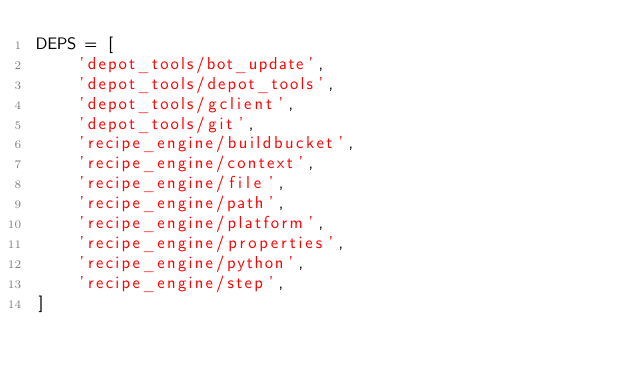Convert code to text. <code><loc_0><loc_0><loc_500><loc_500><_Python_>DEPS = [
    'depot_tools/bot_update',
    'depot_tools/depot_tools',
    'depot_tools/gclient',
    'depot_tools/git',
    'recipe_engine/buildbucket',
    'recipe_engine/context',
    'recipe_engine/file',
    'recipe_engine/path',
    'recipe_engine/platform',
    'recipe_engine/properties',
    'recipe_engine/python',
    'recipe_engine/step',
]
</code> 